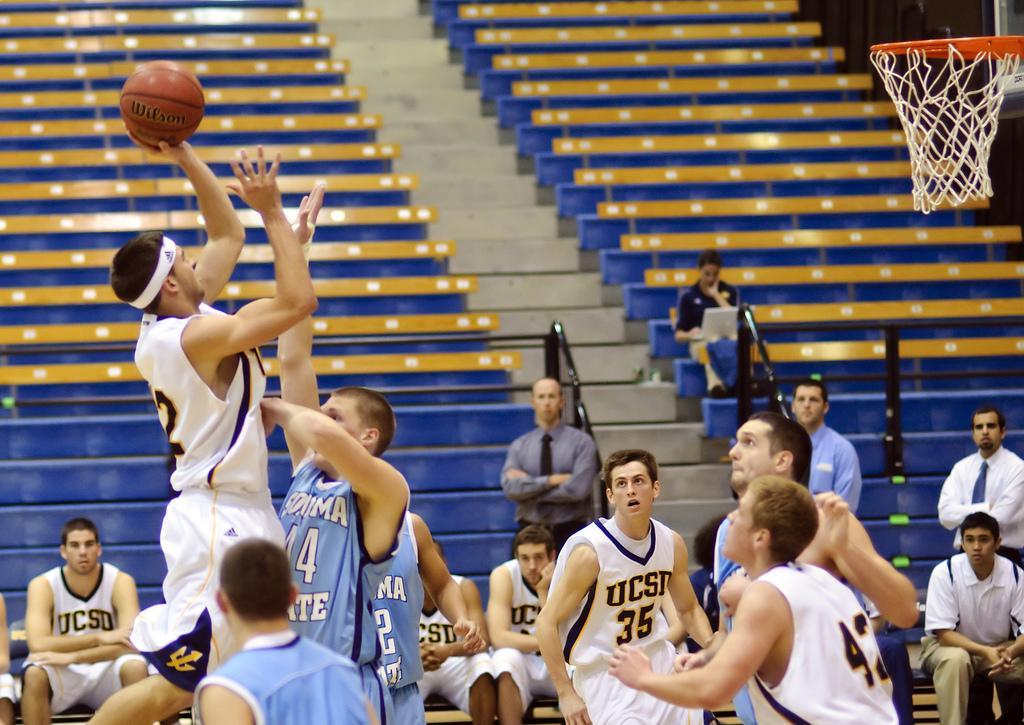Can you describe this image briefly? In this image we can see one stadium, some objects are on the surface, one basketball net, one ball, some people are sitting, some objects are attached to the wall, some people are playing basketball, some objects are on the surface, one pole, one person is sitting and working on the laptop. 